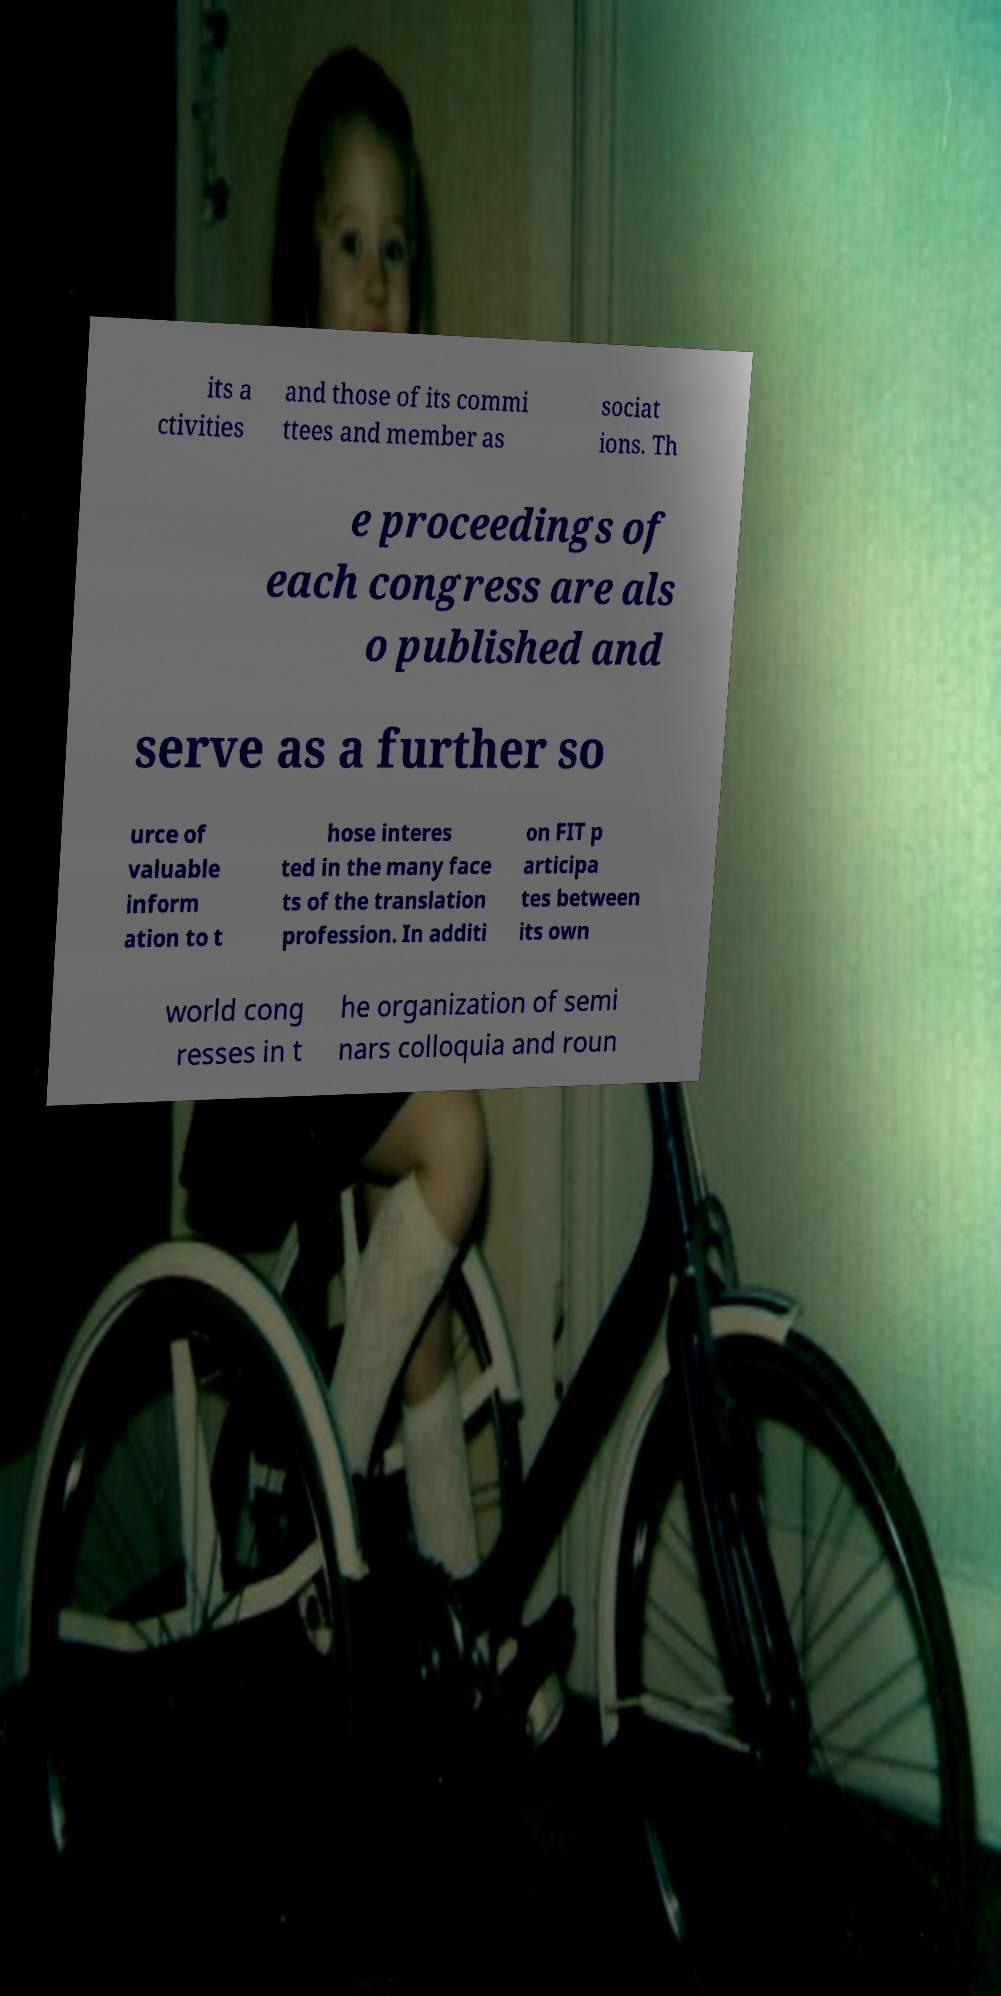What messages or text are displayed in this image? I need them in a readable, typed format. its a ctivities and those of its commi ttees and member as sociat ions. Th e proceedings of each congress are als o published and serve as a further so urce of valuable inform ation to t hose interes ted in the many face ts of the translation profession. In additi on FIT p articipa tes between its own world cong resses in t he organization of semi nars colloquia and roun 